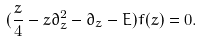Convert formula to latex. <formula><loc_0><loc_0><loc_500><loc_500>( \frac { z } { 4 } - z \partial _ { z } ^ { 2 } - \partial _ { z } - E ) f ( z ) = 0 .</formula> 